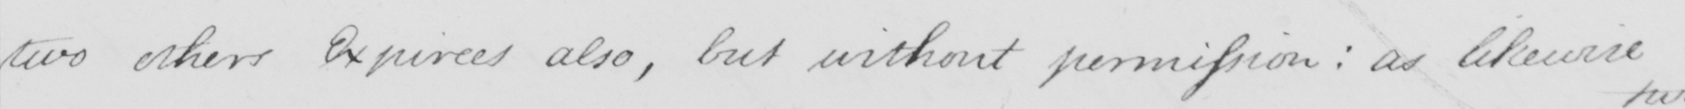Please transcribe the handwritten text in this image. two other Expirees also , but without permission :  as likewise 